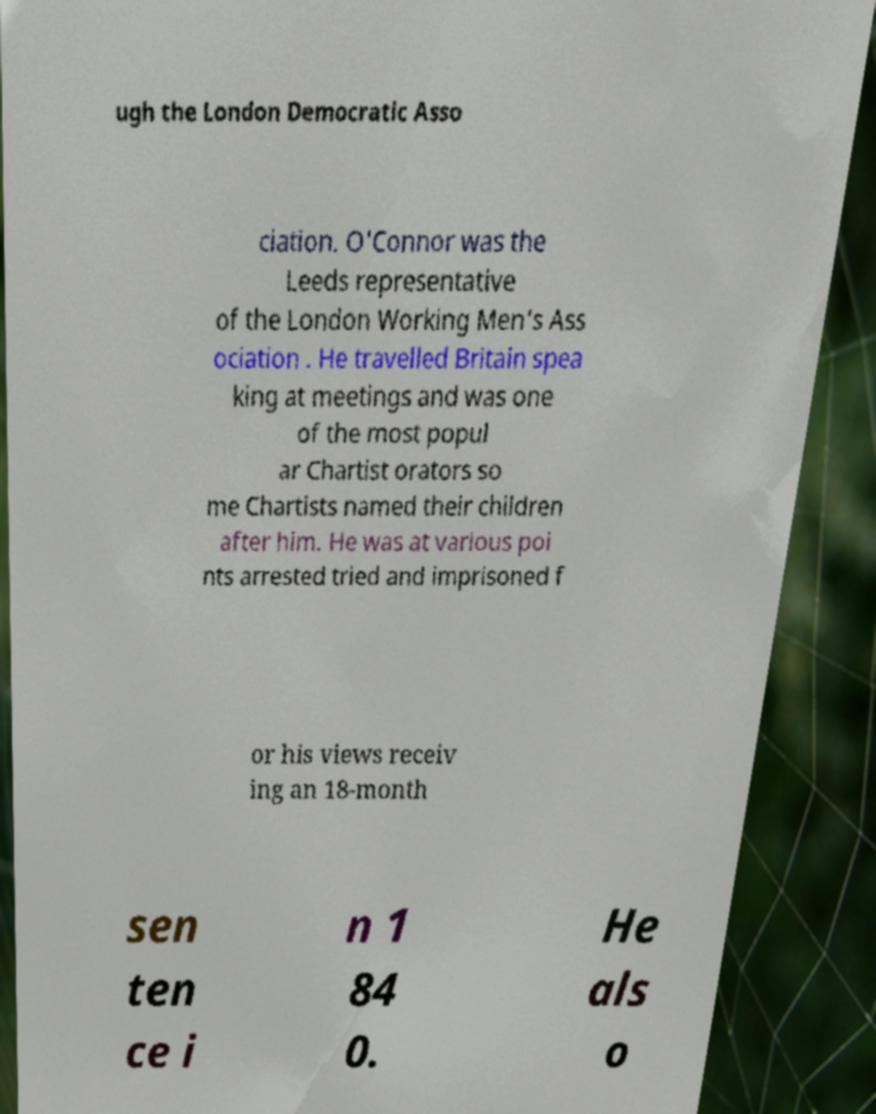What messages or text are displayed in this image? I need them in a readable, typed format. ugh the London Democratic Asso ciation. O'Connor was the Leeds representative of the London Working Men's Ass ociation . He travelled Britain spea king at meetings and was one of the most popul ar Chartist orators so me Chartists named their children after him. He was at various poi nts arrested tried and imprisoned f or his views receiv ing an 18-month sen ten ce i n 1 84 0. He als o 